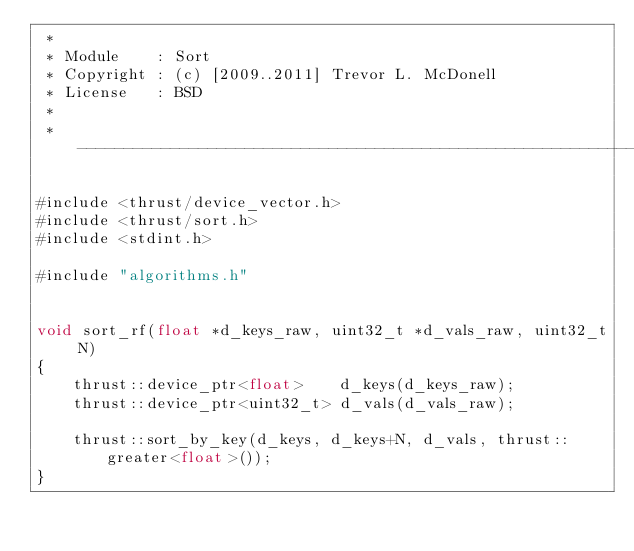<code> <loc_0><loc_0><loc_500><loc_500><_Cuda_> *
 * Module    : Sort
 * Copyright : (c) [2009..2011] Trevor L. McDonell
 * License   : BSD
 *
 * ---------------------------------------------------------------------------*/

#include <thrust/device_vector.h>
#include <thrust/sort.h>
#include <stdint.h>

#include "algorithms.h"


void sort_rf(float *d_keys_raw, uint32_t *d_vals_raw, uint32_t N)
{
    thrust::device_ptr<float>    d_keys(d_keys_raw);
    thrust::device_ptr<uint32_t> d_vals(d_vals_raw);

    thrust::sort_by_key(d_keys, d_keys+N, d_vals, thrust::greater<float>());
}

</code> 